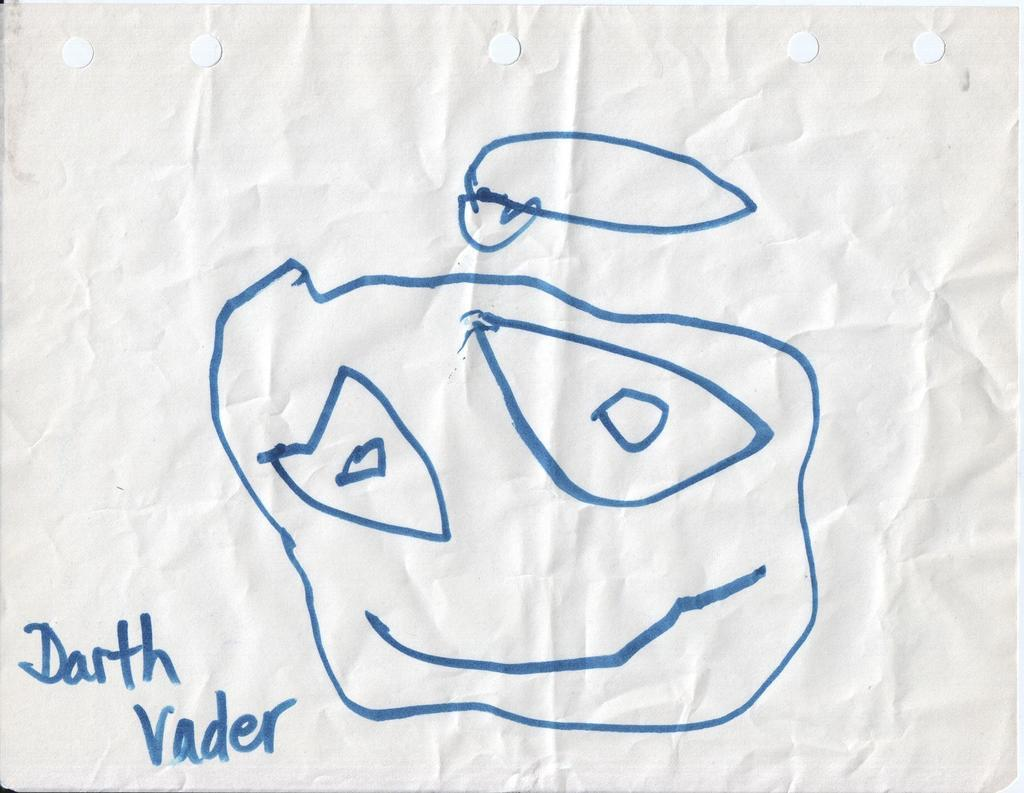What is present on the paper in the image? There is a drawing on the paper. Can you describe the drawing on the paper? Unfortunately, the details of the drawing cannot be determined from the provided facts. What is the primary purpose of the paper in the image? The primary purpose of the paper in the image is to display the drawing. What type of disease is being treated at the market in the image? There is no mention of a market or a disease in the image; it only features a paper with a drawing on it. 